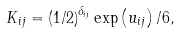Convert formula to latex. <formula><loc_0><loc_0><loc_500><loc_500>K _ { i j } = \left ( 1 / 2 \right ) ^ { \delta _ { i j } } \exp \left ( u _ { i j } \right ) / 6 ,</formula> 